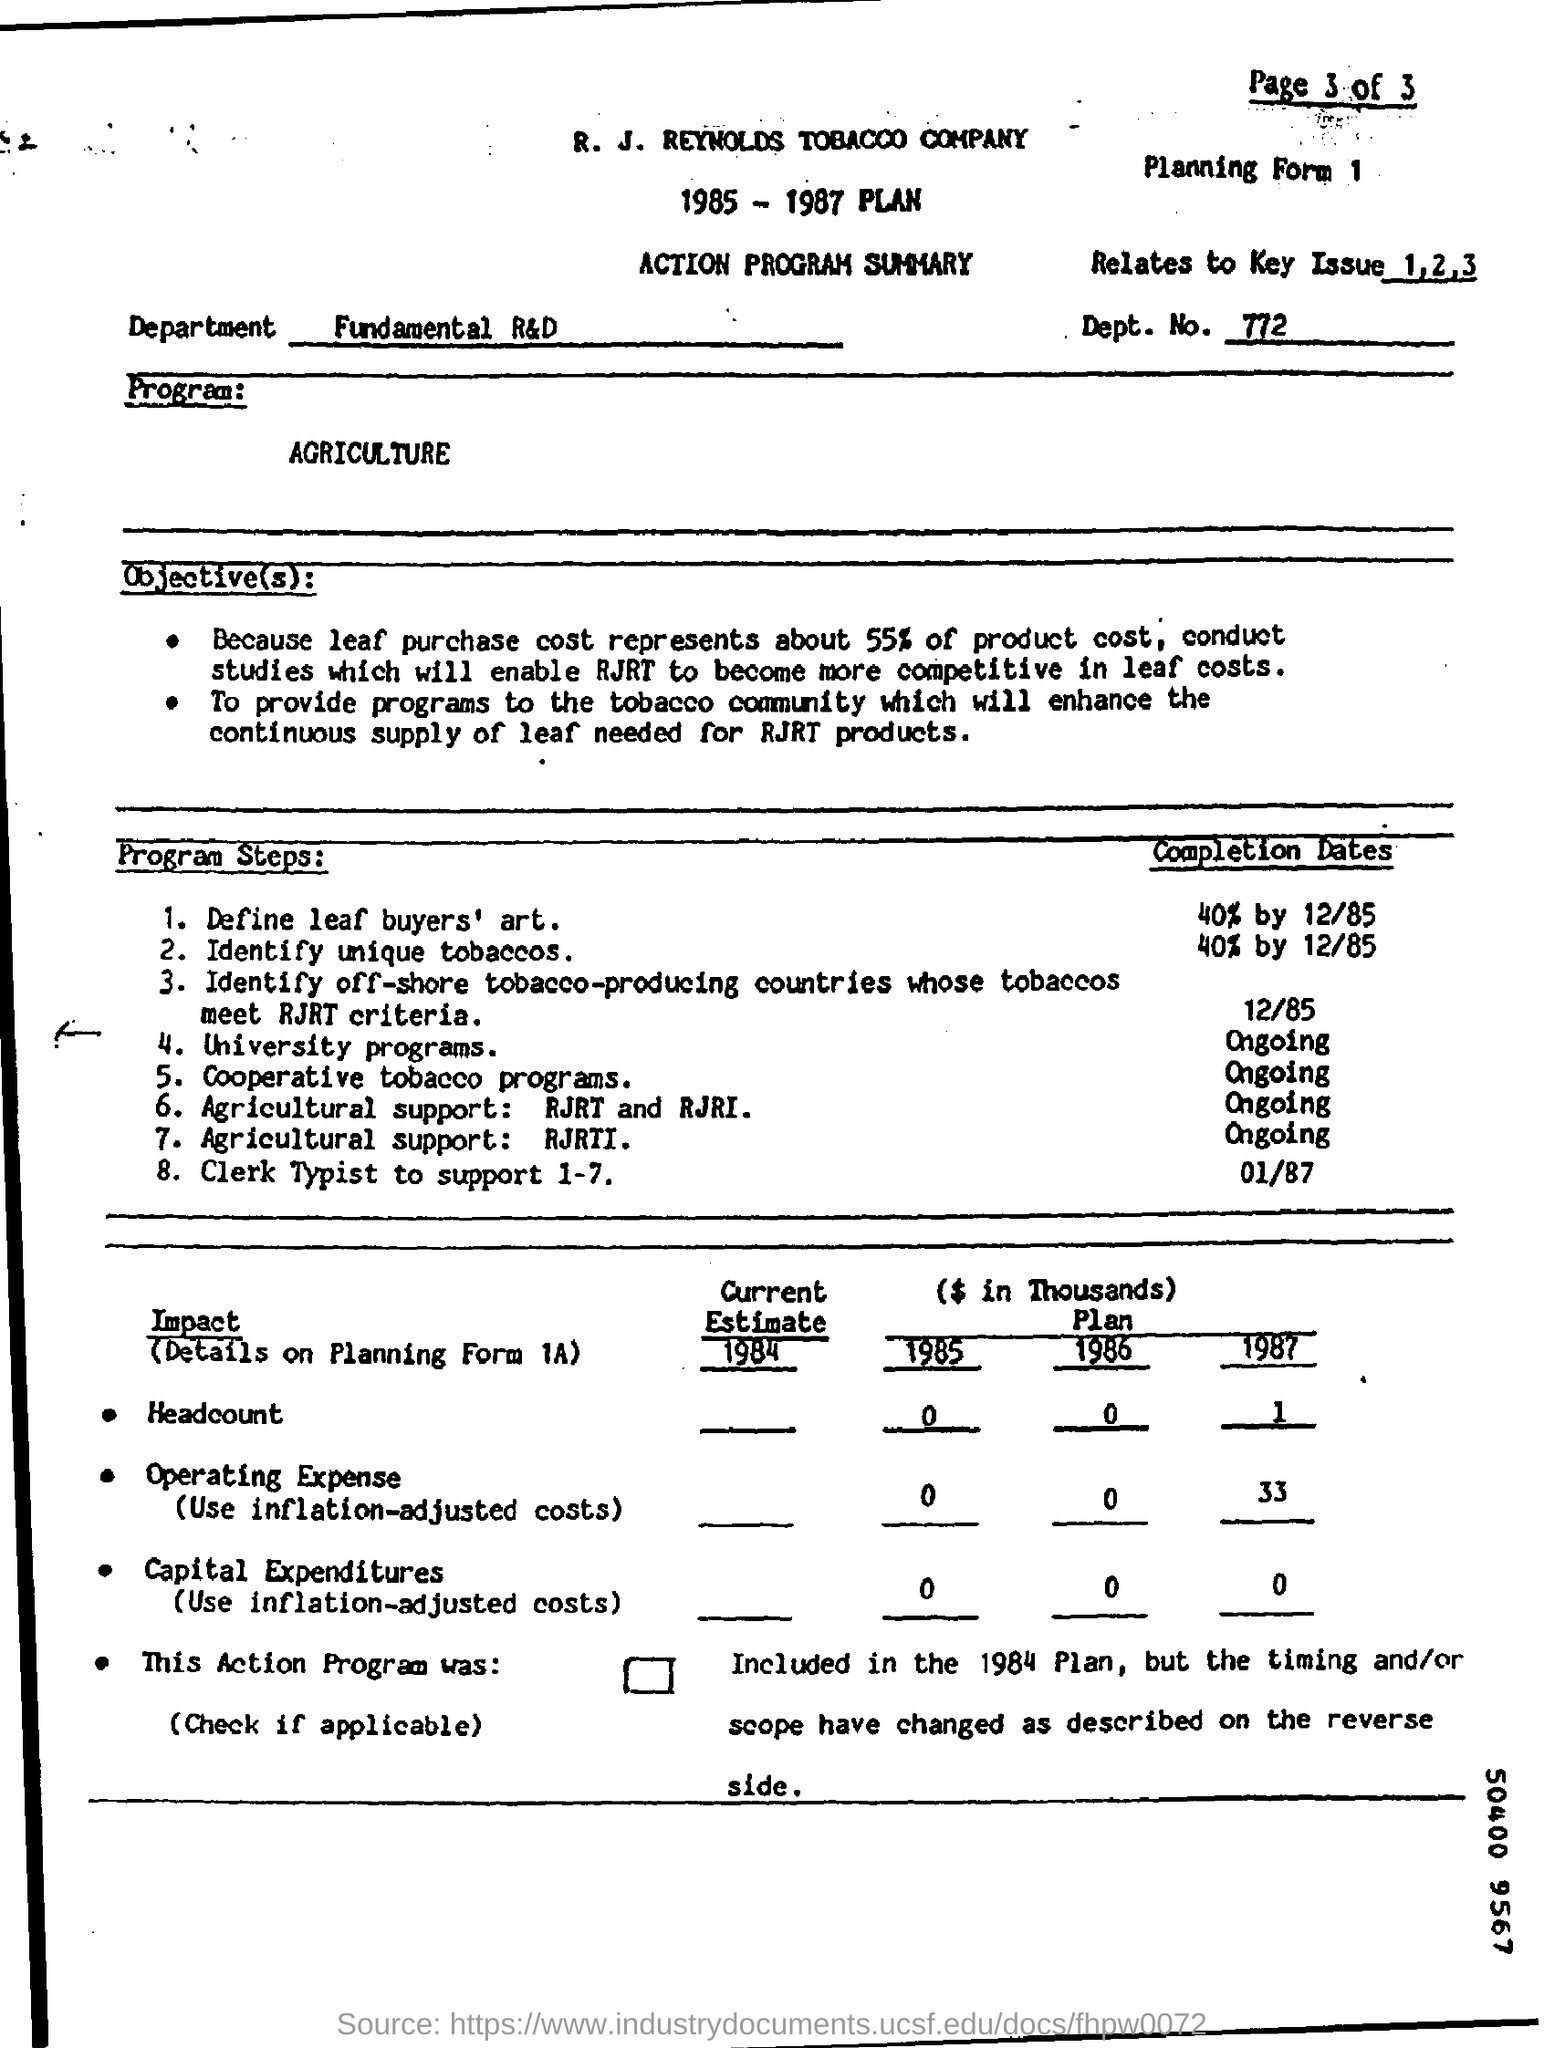Specify some key components in this picture. The written text in the Department Field reads "Fundamental R&D. The R. J. Reynolds Tobacco Company is the name of a company. The Relates to Key Issue field contains information regarding the relationship between the document and the key issue, including numbers 1, 2, and 3. The Program Field contains the word 'Agriculture'. 